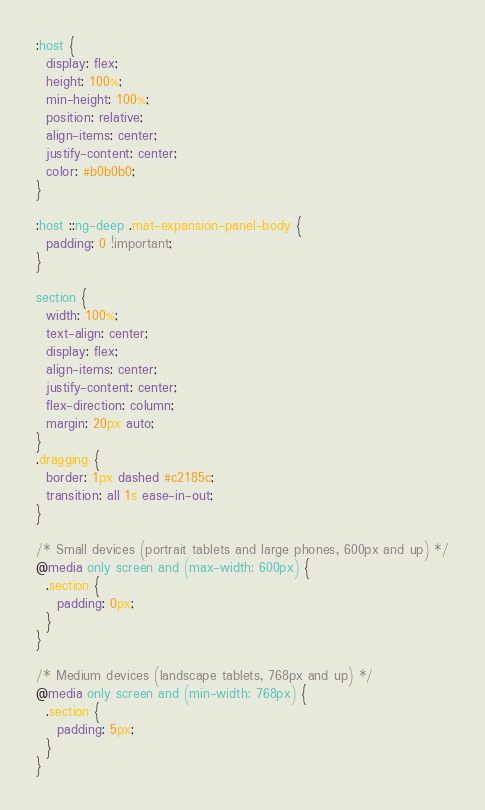<code> <loc_0><loc_0><loc_500><loc_500><_CSS_>:host {
  display: flex;
  height: 100%;
  min-height: 100%;
  position: relative;
  align-items: center;
  justify-content: center;
  color: #b0b0b0;
}

:host ::ng-deep .mat-expansion-panel-body {
  padding: 0 !important;
}

section {
  width: 100%;
  text-align: center;
  display: flex;
  align-items: center;
  justify-content: center;
  flex-direction: column;
  margin: 20px auto;
}
.dragging {
  border: 1px dashed #c2185c;
  transition: all 1s ease-in-out;
}

/* Small devices (portrait tablets and large phones, 600px and up) */
@media only screen and (max-width: 600px) {
  .section {
    padding: 0px;
  }
}

/* Medium devices (landscape tablets, 768px and up) */
@media only screen and (min-width: 768px) {
  .section {
    padding: 5px;
  }
}
</code> 